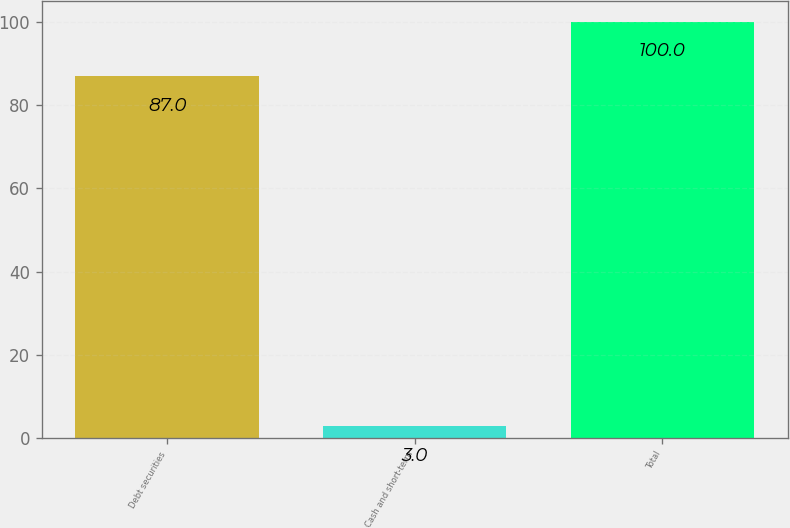Convert chart to OTSL. <chart><loc_0><loc_0><loc_500><loc_500><bar_chart><fcel>Debt securities<fcel>Cash and short-term<fcel>Total<nl><fcel>87<fcel>3<fcel>100<nl></chart> 